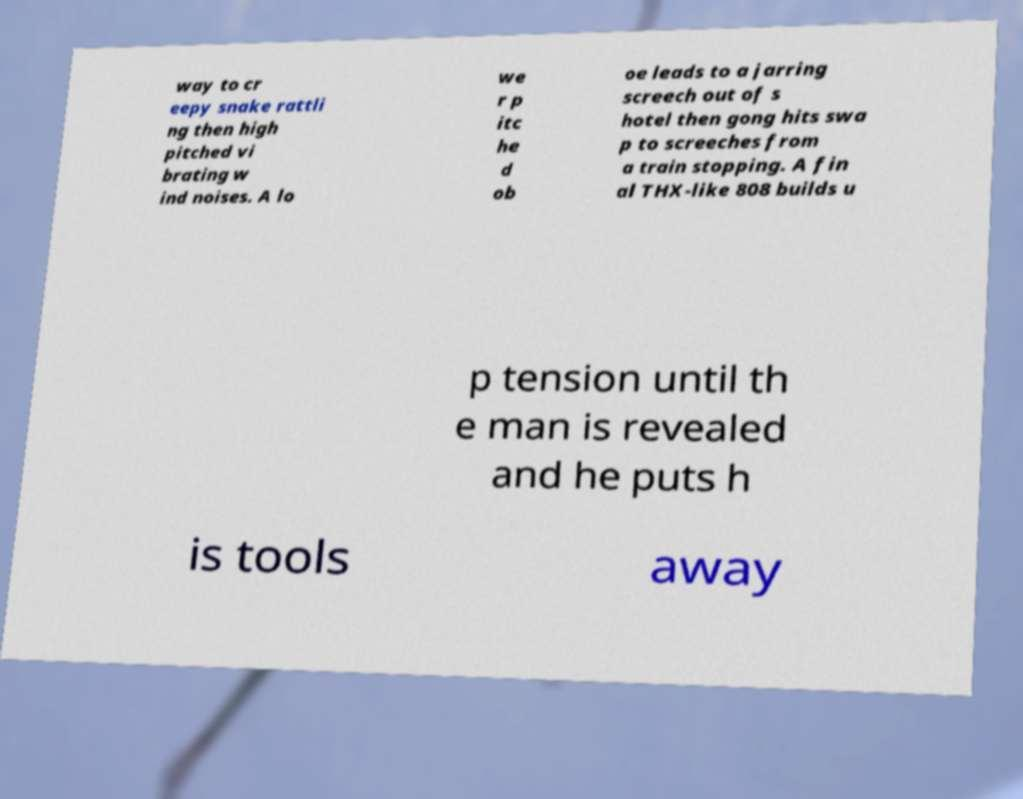Could you assist in decoding the text presented in this image and type it out clearly? way to cr eepy snake rattli ng then high pitched vi brating w ind noises. A lo we r p itc he d ob oe leads to a jarring screech out of s hotel then gong hits swa p to screeches from a train stopping. A fin al THX-like 808 builds u p tension until th e man is revealed and he puts h is tools away 